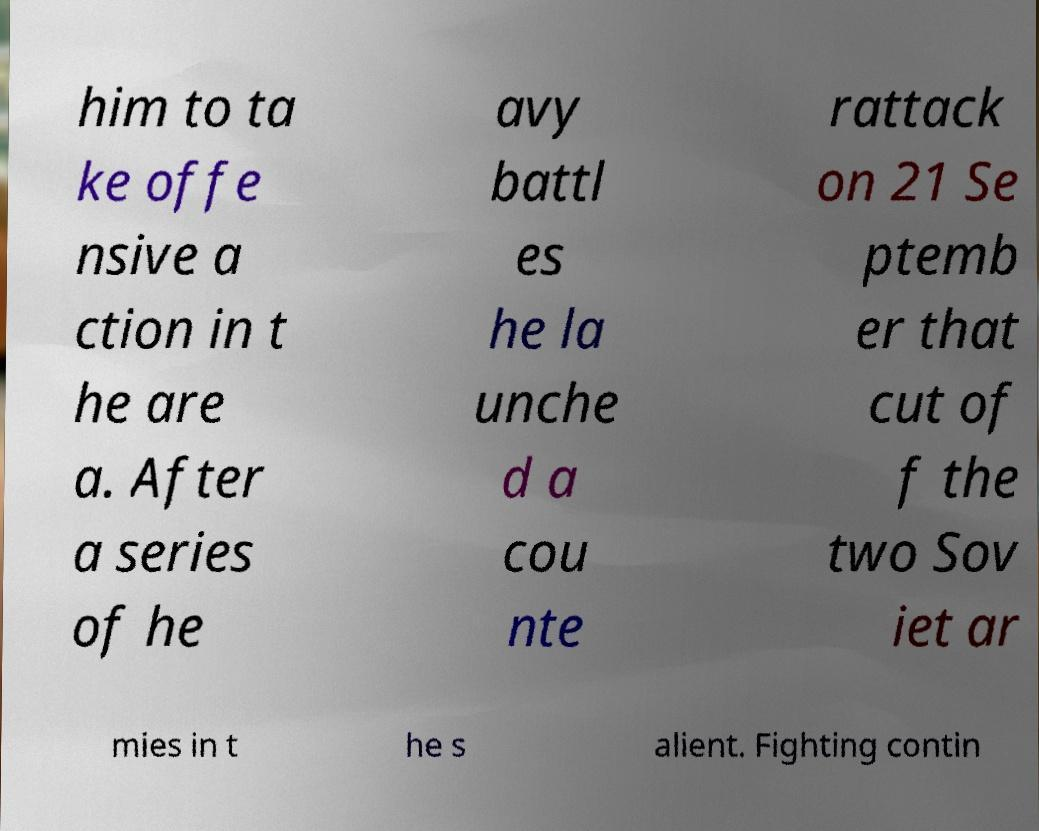Please identify and transcribe the text found in this image. him to ta ke offe nsive a ction in t he are a. After a series of he avy battl es he la unche d a cou nte rattack on 21 Se ptemb er that cut of f the two Sov iet ar mies in t he s alient. Fighting contin 